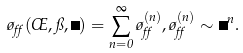Convert formula to latex. <formula><loc_0><loc_0><loc_500><loc_500>\tau _ { \alpha } ( \phi , \pi , \Phi ) = \sum _ { n = 0 } ^ { \infty } \tau _ { \alpha } ^ { ( n ) } , \tau _ { \alpha } ^ { ( n ) } \sim \Phi ^ { n } .</formula> 